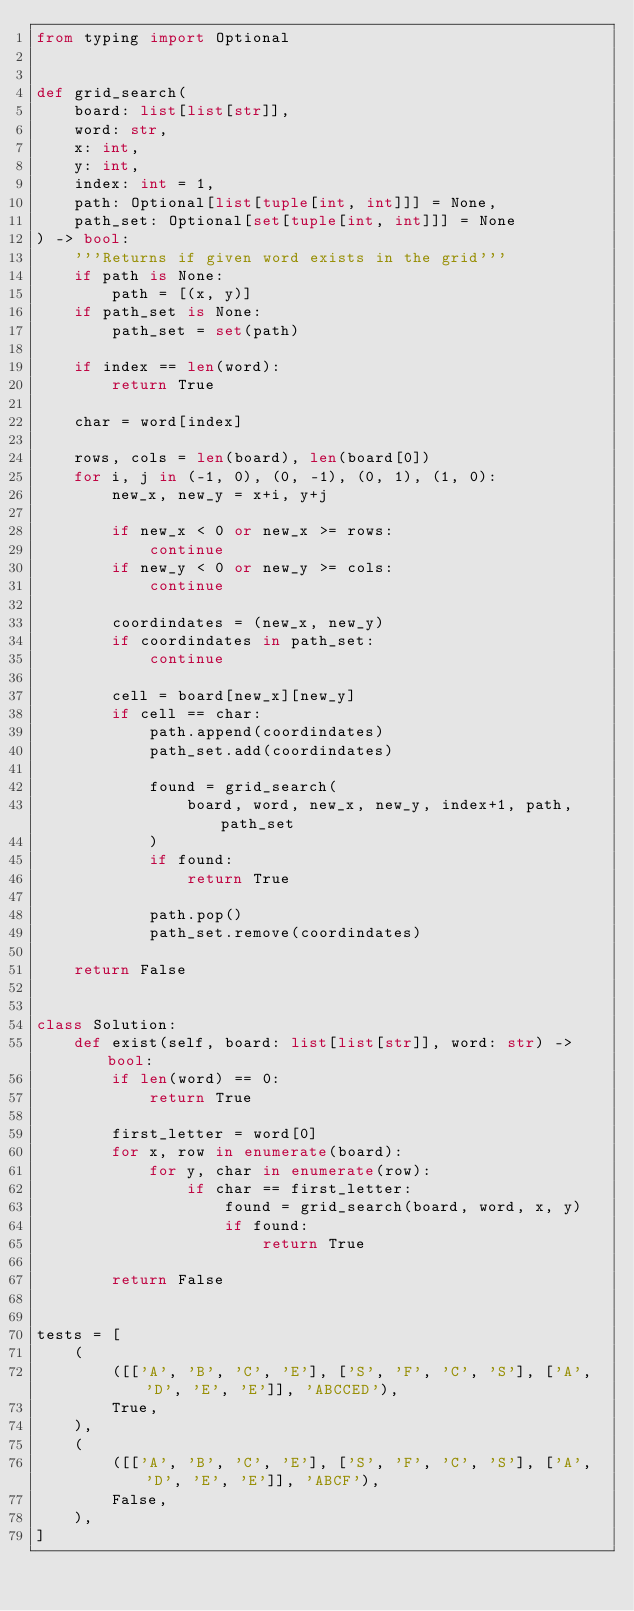Convert code to text. <code><loc_0><loc_0><loc_500><loc_500><_Python_>from typing import Optional


def grid_search(
    board: list[list[str]],
    word: str,
    x: int,
    y: int,
    index: int = 1,
    path: Optional[list[tuple[int, int]]] = None,
    path_set: Optional[set[tuple[int, int]]] = None
) -> bool:
    '''Returns if given word exists in the grid'''
    if path is None:
        path = [(x, y)]
    if path_set is None:
        path_set = set(path)

    if index == len(word):
        return True

    char = word[index]

    rows, cols = len(board), len(board[0])
    for i, j in (-1, 0), (0, -1), (0, 1), (1, 0):
        new_x, new_y = x+i, y+j

        if new_x < 0 or new_x >= rows:
            continue
        if new_y < 0 or new_y >= cols:
            continue

        coordindates = (new_x, new_y)
        if coordindates in path_set:
            continue

        cell = board[new_x][new_y]
        if cell == char:
            path.append(coordindates)
            path_set.add(coordindates)

            found = grid_search(
                board, word, new_x, new_y, index+1, path, path_set
            )
            if found:
                return True

            path.pop()
            path_set.remove(coordindates)

    return False


class Solution:
    def exist(self, board: list[list[str]], word: str) -> bool:
        if len(word) == 0:
            return True

        first_letter = word[0]
        for x, row in enumerate(board):
            for y, char in enumerate(row):
                if char == first_letter:
                    found = grid_search(board, word, x, y)
                    if found:
                        return True

        return False


tests = [
    (
        ([['A', 'B', 'C', 'E'], ['S', 'F', 'C', 'S'], ['A', 'D', 'E', 'E']], 'ABCCED'),
        True,
    ),
    (
        ([['A', 'B', 'C', 'E'], ['S', 'F', 'C', 'S'], ['A', 'D', 'E', 'E']], 'ABCF'),
        False,
    ),
]
</code> 